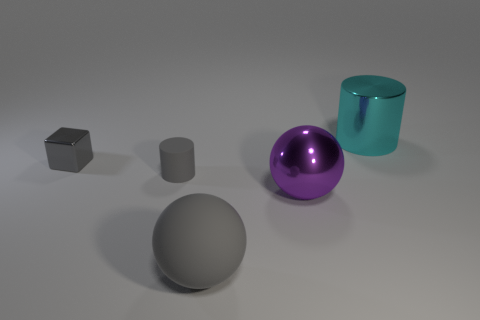What can the arrangement of these objects tell us? The arrangement of objects seems deliberately spaced, which may indicate a controlled study of shapes and materials. Each object is distinct in shape and finish, allowing the viewer to compare and contrast their characteristics. The spacing also ensures that the shadows of each object do not overlap, which could be a conscious choice if the purpose is to study the objects' individual properties in detail. 